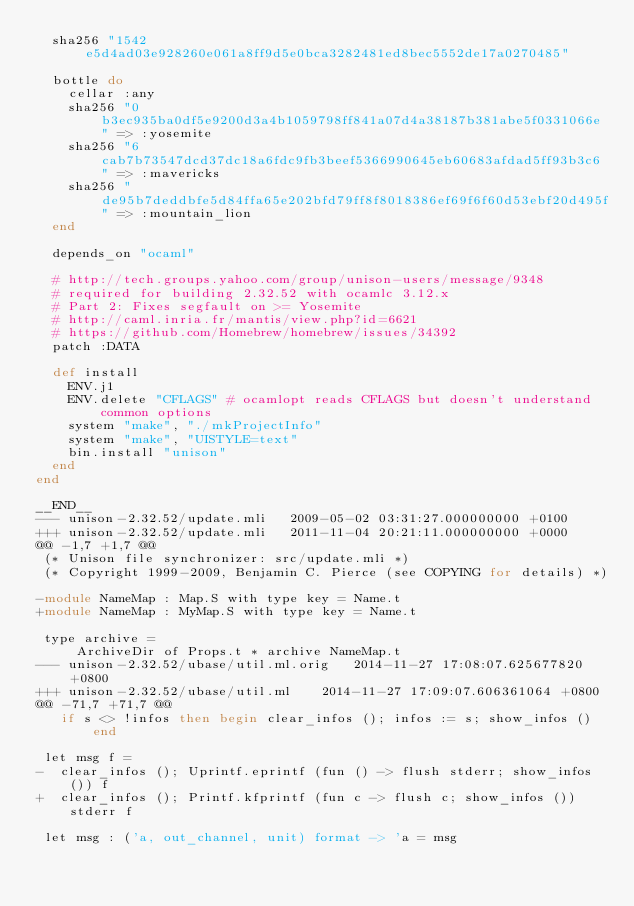<code> <loc_0><loc_0><loc_500><loc_500><_Ruby_>  sha256 "1542e5d4ad03e928260e061a8ff9d5e0bca3282481ed8bec5552de17a0270485"

  bottle do
    cellar :any
    sha256 "0b3ec935ba0df5e9200d3a4b1059798ff841a07d4a38187b381abe5f0331066e" => :yosemite
    sha256 "6cab7b73547dcd37dc18a6fdc9fb3beef5366990645eb60683afdad5ff93b3c6" => :mavericks
    sha256 "de95b7deddbfe5d84ffa65e202bfd79ff8f8018386ef69f6f60d53ebf20d495f" => :mountain_lion
  end

  depends_on "ocaml"

  # http://tech.groups.yahoo.com/group/unison-users/message/9348
  # required for building 2.32.52 with ocamlc 3.12.x
  # Part 2: Fixes segfault on >= Yosemite
  # http://caml.inria.fr/mantis/view.php?id=6621
  # https://github.com/Homebrew/homebrew/issues/34392
  patch :DATA

  def install
    ENV.j1
    ENV.delete "CFLAGS" # ocamlopt reads CFLAGS but doesn't understand common options
    system "make", "./mkProjectInfo"
    system "make", "UISTYLE=text"
    bin.install "unison"
  end
end

__END__
--- unison-2.32.52/update.mli	2009-05-02 03:31:27.000000000 +0100
+++ unison-2.32.52/update.mli	2011-11-04 20:21:11.000000000 +0000
@@ -1,7 +1,7 @@
 (* Unison file synchronizer: src/update.mli *)
 (* Copyright 1999-2009, Benjamin C. Pierce (see COPYING for details) *)
 
-module NameMap : Map.S with type key = Name.t
+module NameMap : MyMap.S with type key = Name.t
 
 type archive =
     ArchiveDir of Props.t * archive NameMap.t
--- unison-2.32.52/ubase/util.ml.orig	2014-11-27 17:08:07.625677820 +0800
+++ unison-2.32.52/ubase/util.ml	2014-11-27 17:09:07.606361064 +0800
@@ -71,7 +71,7 @@
   if s <> !infos then begin clear_infos (); infos := s; show_infos () end

 let msg f =
-  clear_infos (); Uprintf.eprintf (fun () -> flush stderr; show_infos ()) f
+  clear_infos (); Printf.kfprintf (fun c -> flush c; show_infos ()) stderr f

 let msg : ('a, out_channel, unit) format -> 'a = msg
</code> 